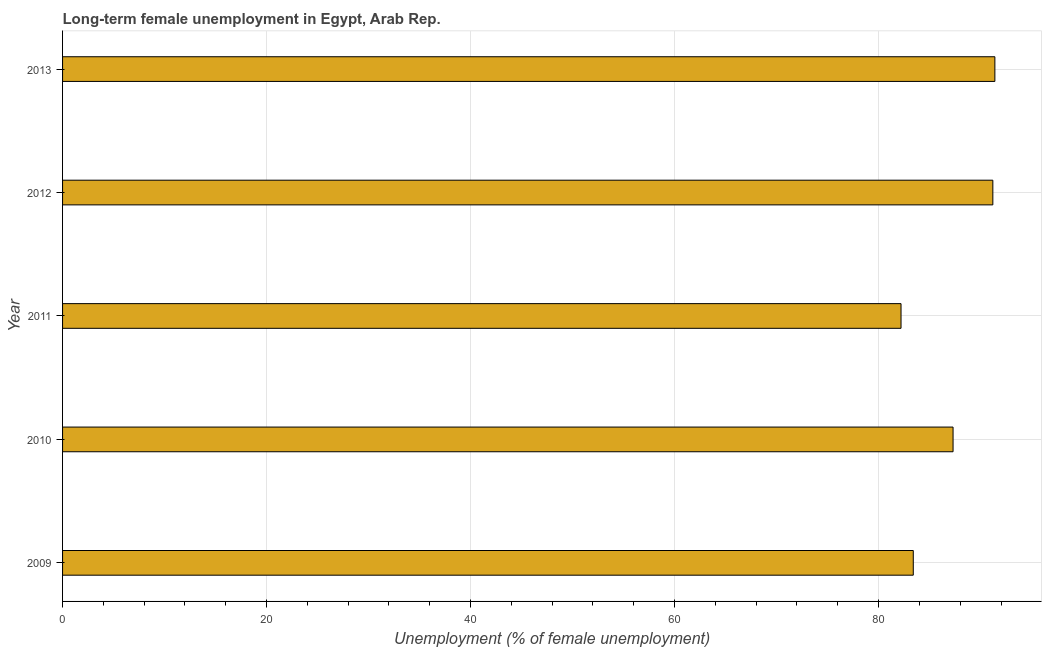What is the title of the graph?
Your answer should be compact. Long-term female unemployment in Egypt, Arab Rep. What is the label or title of the X-axis?
Provide a short and direct response. Unemployment (% of female unemployment). What is the long-term female unemployment in 2010?
Give a very brief answer. 87.3. Across all years, what is the maximum long-term female unemployment?
Make the answer very short. 91.4. Across all years, what is the minimum long-term female unemployment?
Your answer should be very brief. 82.2. In which year was the long-term female unemployment minimum?
Offer a terse response. 2011. What is the sum of the long-term female unemployment?
Keep it short and to the point. 435.5. What is the difference between the long-term female unemployment in 2011 and 2013?
Provide a succinct answer. -9.2. What is the average long-term female unemployment per year?
Give a very brief answer. 87.1. What is the median long-term female unemployment?
Ensure brevity in your answer.  87.3. In how many years, is the long-term female unemployment greater than 44 %?
Give a very brief answer. 5. Do a majority of the years between 2013 and 2012 (inclusive) have long-term female unemployment greater than 40 %?
Give a very brief answer. No. What is the ratio of the long-term female unemployment in 2009 to that in 2011?
Your answer should be compact. 1.01. Is the long-term female unemployment in 2011 less than that in 2012?
Ensure brevity in your answer.  Yes. What is the difference between the highest and the second highest long-term female unemployment?
Your response must be concise. 0.2. Is the sum of the long-term female unemployment in 2010 and 2013 greater than the maximum long-term female unemployment across all years?
Offer a terse response. Yes. What is the difference between the highest and the lowest long-term female unemployment?
Provide a short and direct response. 9.2. Are all the bars in the graph horizontal?
Provide a succinct answer. Yes. How many years are there in the graph?
Offer a terse response. 5. Are the values on the major ticks of X-axis written in scientific E-notation?
Your answer should be very brief. No. What is the Unemployment (% of female unemployment) of 2009?
Keep it short and to the point. 83.4. What is the Unemployment (% of female unemployment) of 2010?
Provide a succinct answer. 87.3. What is the Unemployment (% of female unemployment) in 2011?
Your answer should be compact. 82.2. What is the Unemployment (% of female unemployment) of 2012?
Make the answer very short. 91.2. What is the Unemployment (% of female unemployment) of 2013?
Keep it short and to the point. 91.4. What is the difference between the Unemployment (% of female unemployment) in 2010 and 2011?
Your answer should be very brief. 5.1. What is the difference between the Unemployment (% of female unemployment) in 2010 and 2012?
Your response must be concise. -3.9. What is the difference between the Unemployment (% of female unemployment) in 2011 and 2013?
Ensure brevity in your answer.  -9.2. What is the difference between the Unemployment (% of female unemployment) in 2012 and 2013?
Keep it short and to the point. -0.2. What is the ratio of the Unemployment (% of female unemployment) in 2009 to that in 2010?
Make the answer very short. 0.95. What is the ratio of the Unemployment (% of female unemployment) in 2009 to that in 2012?
Your answer should be compact. 0.91. What is the ratio of the Unemployment (% of female unemployment) in 2009 to that in 2013?
Your response must be concise. 0.91. What is the ratio of the Unemployment (% of female unemployment) in 2010 to that in 2011?
Offer a very short reply. 1.06. What is the ratio of the Unemployment (% of female unemployment) in 2010 to that in 2012?
Offer a terse response. 0.96. What is the ratio of the Unemployment (% of female unemployment) in 2010 to that in 2013?
Your answer should be compact. 0.95. What is the ratio of the Unemployment (% of female unemployment) in 2011 to that in 2012?
Your answer should be compact. 0.9. What is the ratio of the Unemployment (% of female unemployment) in 2011 to that in 2013?
Your answer should be compact. 0.9. 